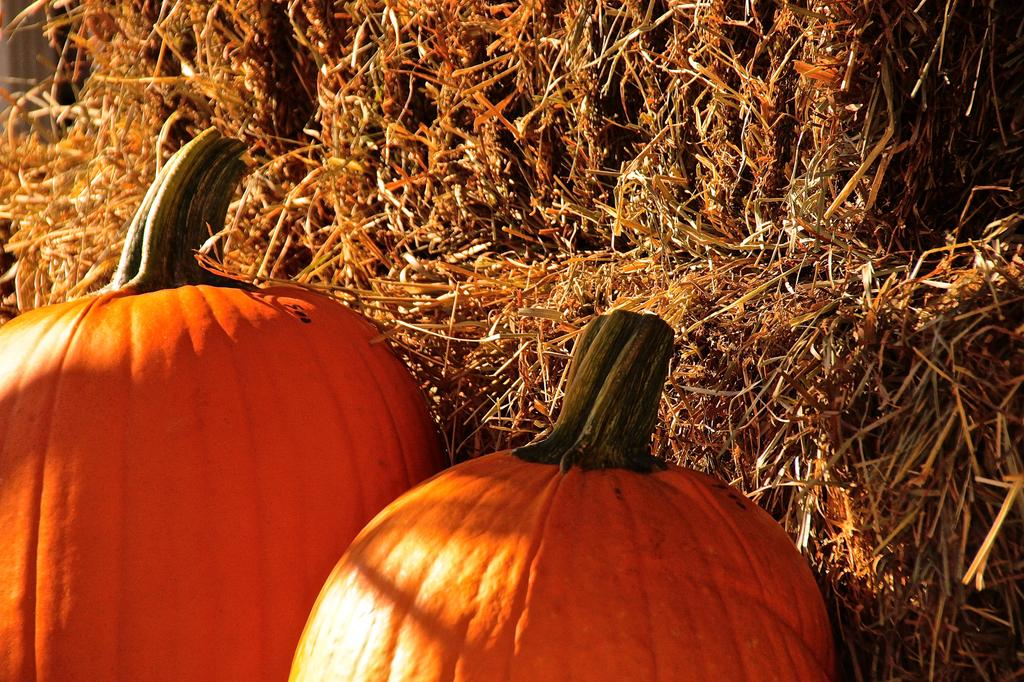What objects are in the front of the image? There are two pumpkins in the front of the image. What type of vegetation can be seen in the background of the image? There is grass visible in the background of the image. How many bags are visible in the image? There are no bags present in the image. 